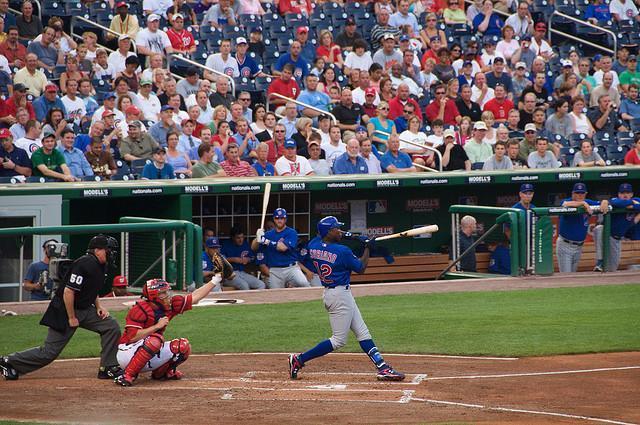How many people can you see?
Give a very brief answer. 4. 